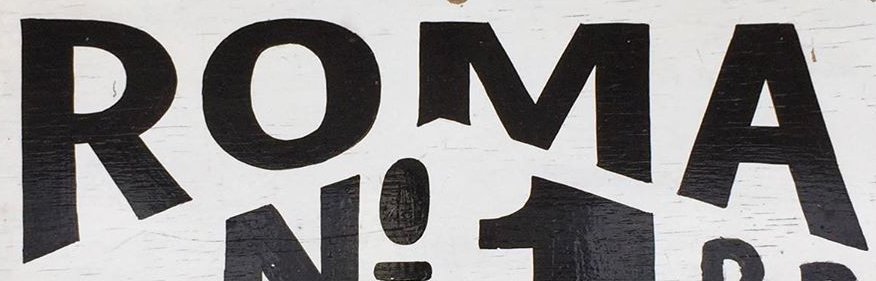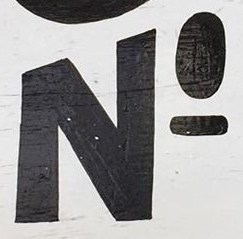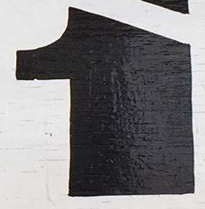Read the text from these images in sequence, separated by a semicolon. ROMA; NO; 1 